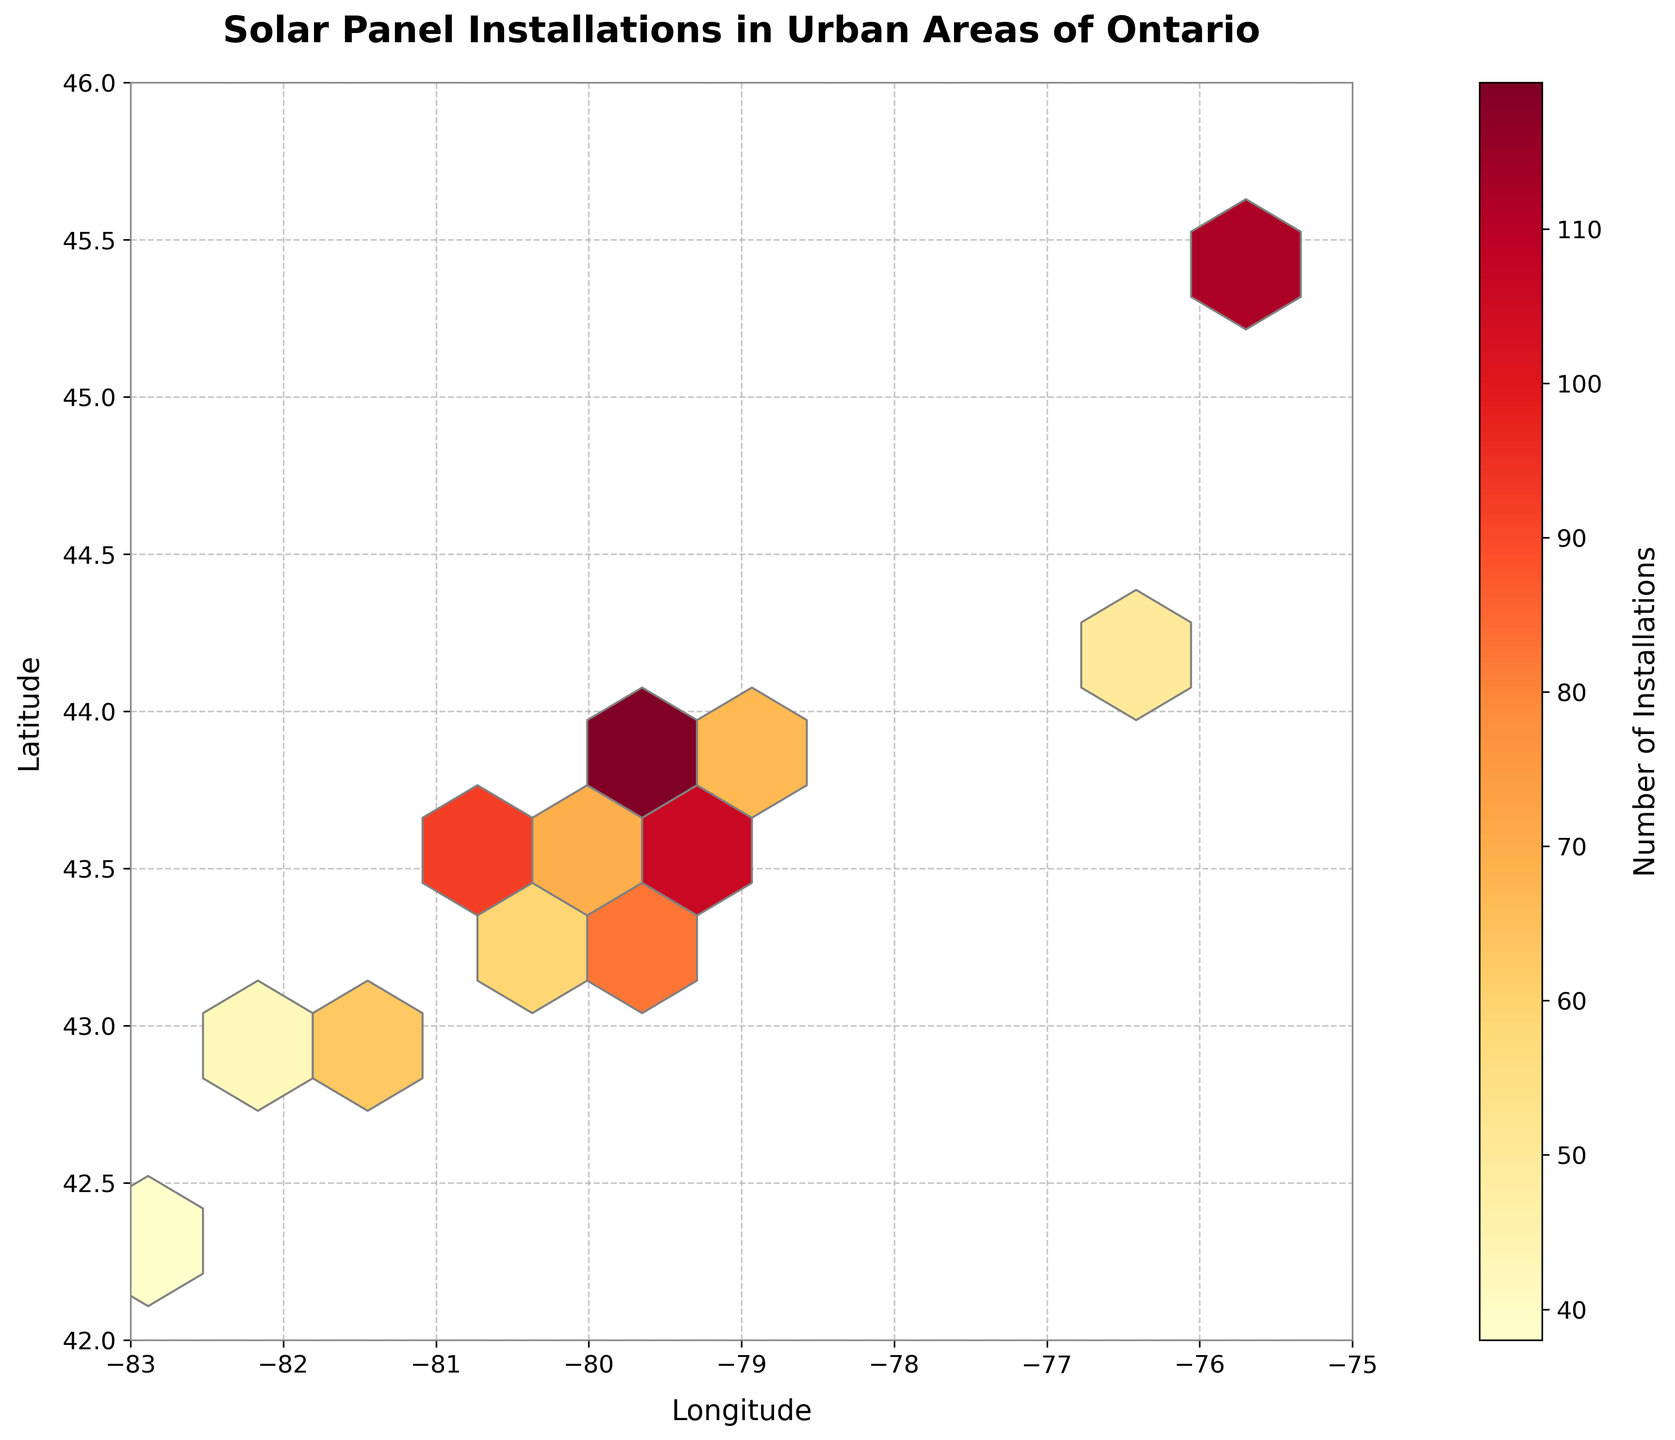What is the title of the figure? The title is typically found at the top of the figure and is clearly labeled as "Solar Panel Installations in Urban Areas of Ontario".
Answer: Solar Panel Installations in Urban Areas of Ontario What does the color intensity represent in the hexbin plot? The color intensity is explained in the colorbar on the right side of the figure. Colors change from light to dark to represent the number of installations.
Answer: Number of installations Which city appears to have the highest concentration of solar panel installations? By looking for the darkest hexbin, we identify the densest region. This region is around the coordinates for Toronto, with approximately 145 installations.
Answer: Toronto What does the x-axis represent? The x-axis is labeled at the bottom of the figure. It represents the "Longitude" of the locations where solar panels are installed.
Answer: Longitude Identify the general trend observed between latitude and the number of installations. Observing the hexbin plot, the areas with more solar panel installations are generally concentrated at lower latitudes around the southern part of Ontario.
Answer: More installations at lower latitudes How many hexagons are displayed in the plot? Counting each individual hexbin provided in the plot across the grid, considering overlaps and contiguous regions.
Answer: Approximately 10 x 10 grid (100 hexagons) Are there any regions with no installations? Regions with no installations are represented by areas with no colored hexagons, notably outside of the concentrated clusters.
Answer: Yes Compare the number of solar panel installations between Ottawa and Hamilton. By identifying the approximate regions in the hexbin plot for Ottawa and Hamilton, comparing the color intensities, Ottawa shows around 112 installations, Hamilton shows around 89.
Answer: Ottawa has more installations than Hamilton What can you say about the geographic spread of solar panel installations in Ontario's urban areas? The spread of hexagons with varying densities provides insight, indicating that installations are more clustered in southern urban areas, with fewer installations in the northern areas within the given latitude and longitude range.
Answer: More clustered in southern urban areas How does the grid size affect the interpretation of the number of installations? A larger grid size will aggregate more installations into each hexagon, reducing the granularity, while a smaller grid size will provide a more detailed and specific view of the distribution.
Answer: Aggregates installations more or less depending on the grid size 